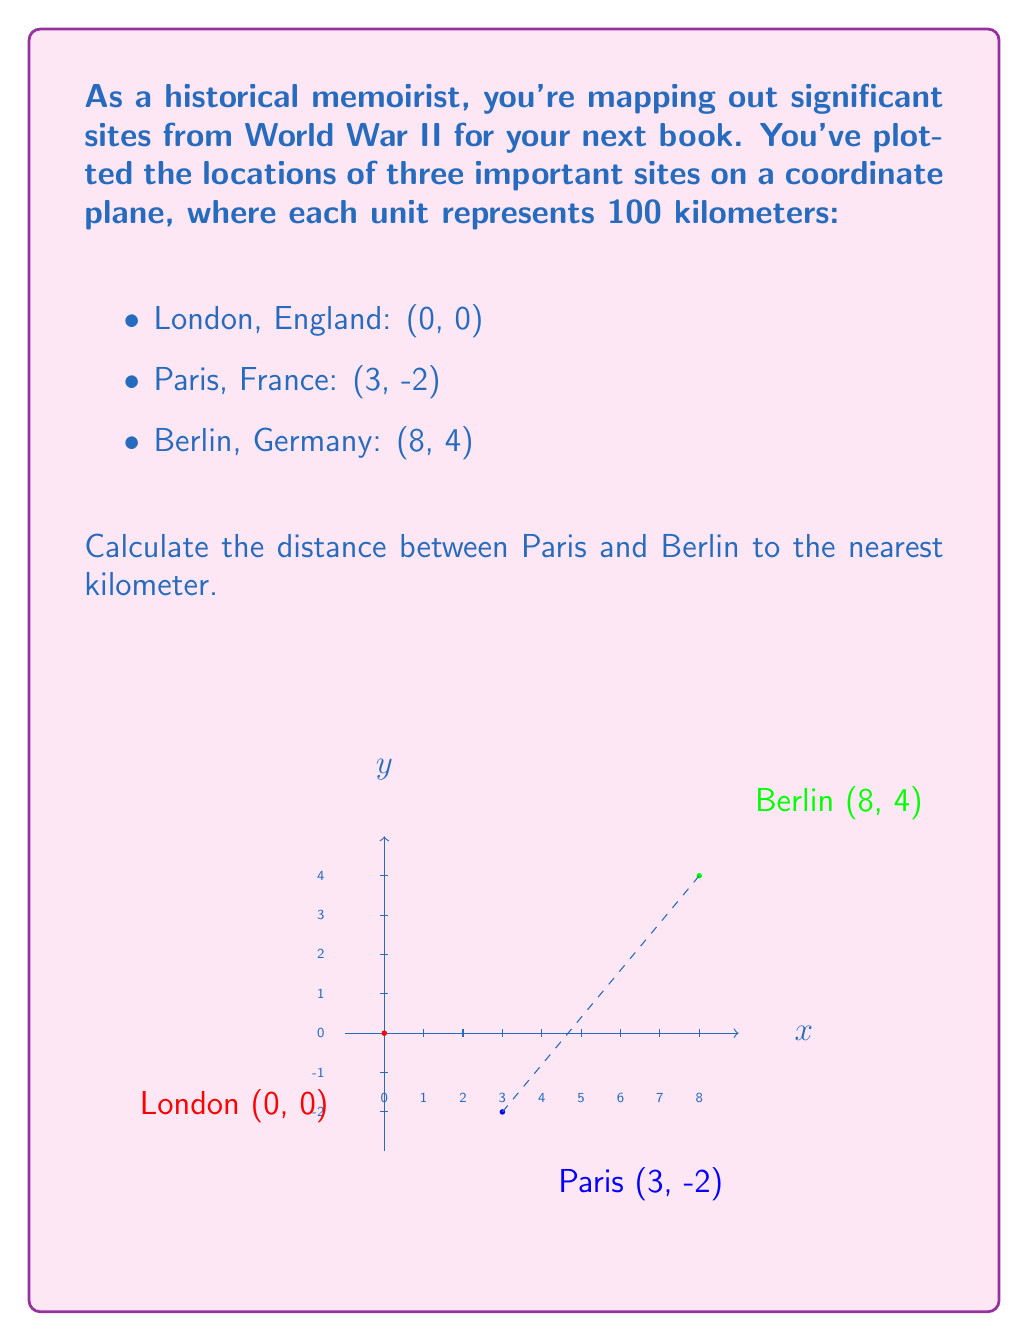Can you solve this math problem? To calculate the distance between Paris and Berlin, we can use the distance formula derived from the Pythagorean theorem:

$$d = \sqrt{(x_2-x_1)^2 + (y_2-y_1)^2}$$

Where $(x_1,y_1)$ represents the coordinates of Paris and $(x_2,y_2)$ represents the coordinates of Berlin.

Step 1: Identify the coordinates
Paris: $(x_1,y_1) = (3,-2)$
Berlin: $(x_2,y_2) = (8,4)$

Step 2: Plug the coordinates into the distance formula
$$d = \sqrt{(8-3)^2 + (4-(-2))^2}$$

Step 3: Simplify the expressions inside the parentheses
$$d = \sqrt{5^2 + 6^2}$$

Step 4: Calculate the squares
$$d = \sqrt{25 + 36}$$

Step 5: Add the values under the square root
$$d = \sqrt{61}$$

Step 6: Calculate the square root
$$d \approx 7.81$$

Step 7: Multiply by 100 km (since each unit represents 100 km)
$$7.81 \times 100 \approx 781 \text{ km}$$

Step 8: Round to the nearest kilometer
$$781 \text{ km}$$
Answer: 781 km 